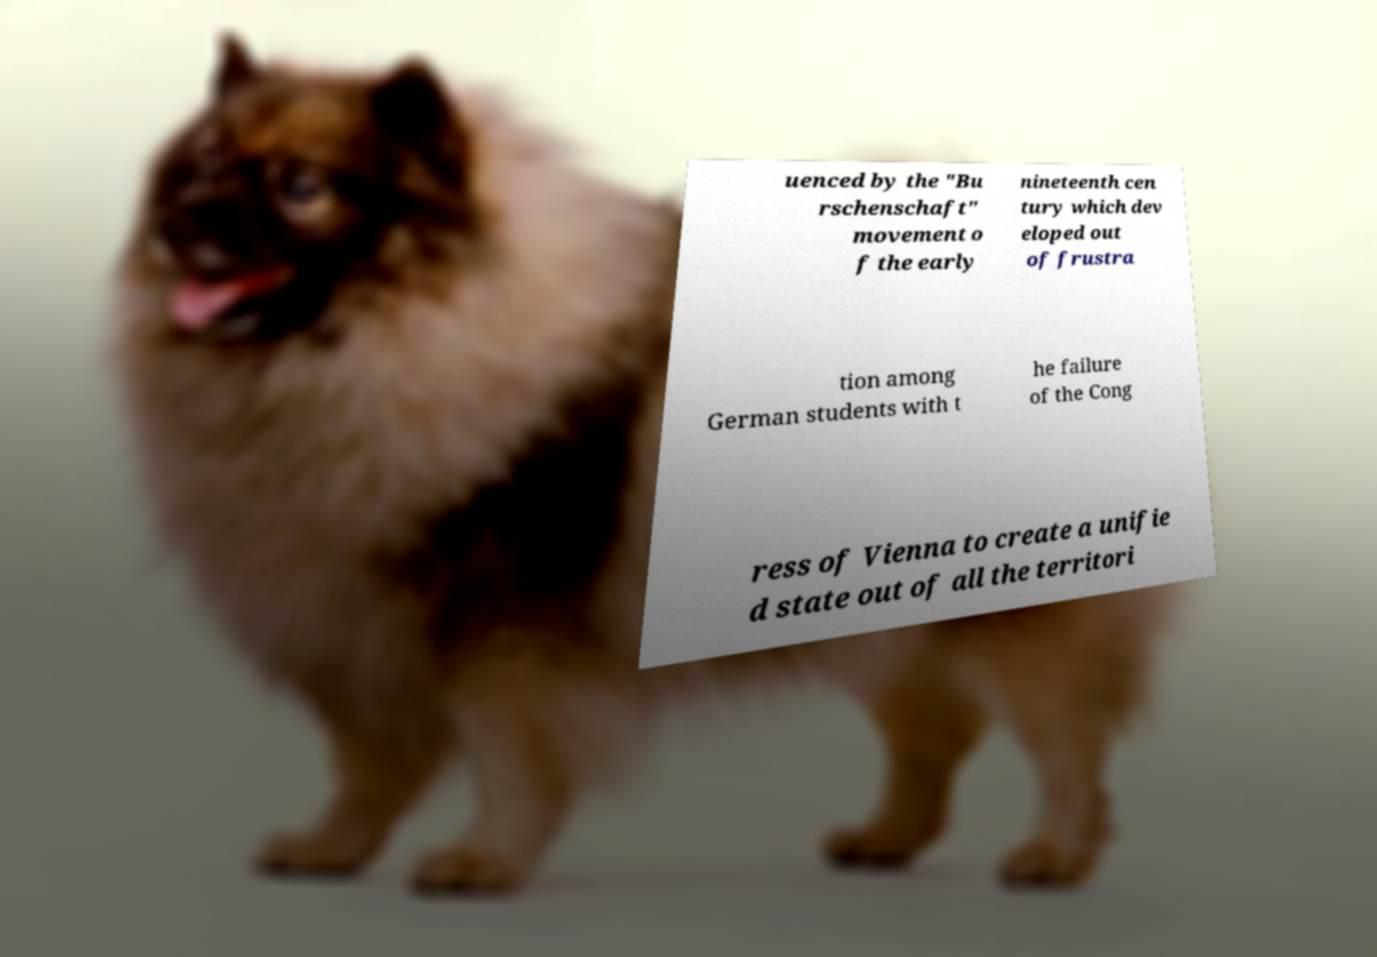What messages or text are displayed in this image? I need them in a readable, typed format. uenced by the "Bu rschenschaft" movement o f the early nineteenth cen tury which dev eloped out of frustra tion among German students with t he failure of the Cong ress of Vienna to create a unifie d state out of all the territori 